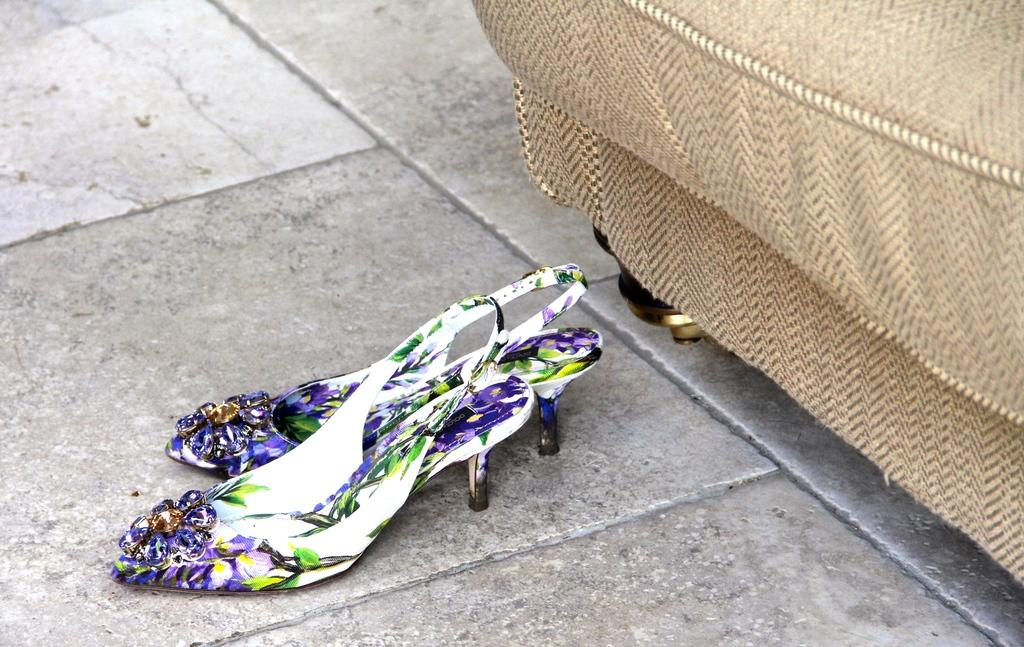What type of footwear is on the floor in the image? There are sandals on the floor in the image. What piece of furniture can be seen in the background of the image? There is a couch in the background of the image. What type of drink is being served on the tiger in the image? There is no tiger or drink present in the image; it only features sandals on the floor and a couch in the background. 